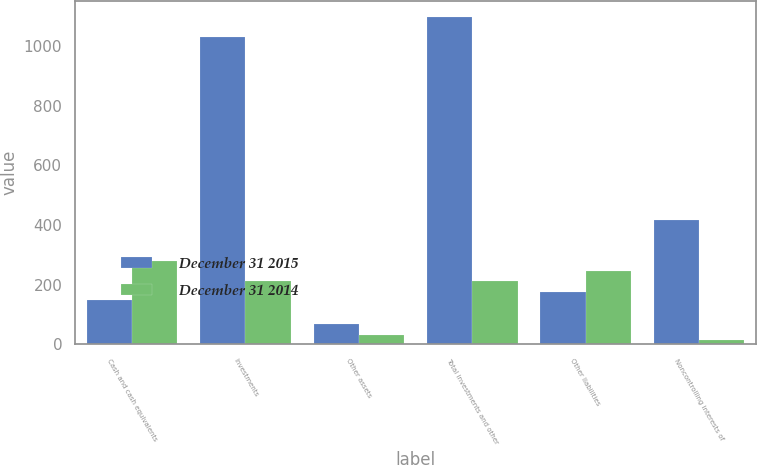Convert chart. <chart><loc_0><loc_0><loc_500><loc_500><stacked_bar_chart><ecel><fcel>Cash and cash equivalents<fcel>Investments<fcel>Other assets<fcel>Total investments and other<fcel>Other liabilities<fcel>Noncontrolling interests of<nl><fcel>December 31 2015<fcel>148<fcel>1030<fcel>67<fcel>1097<fcel>177<fcel>416<nl><fcel>December 31 2014<fcel>278<fcel>211<fcel>32<fcel>211<fcel>245<fcel>15<nl></chart> 